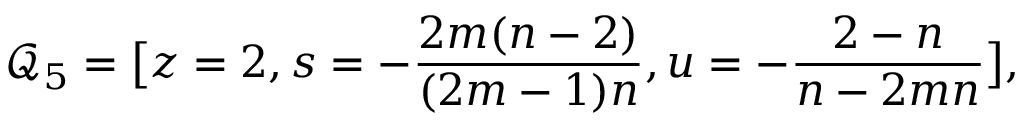<formula> <loc_0><loc_0><loc_500><loc_500>\mathcal { Q } _ { 5 } = \left [ z = 2 , s = - \frac { 2 m ( n - 2 ) } { ( 2 m - 1 ) n } , u = - \frac { 2 - n } { n - 2 m n } \right ] ,</formula> 